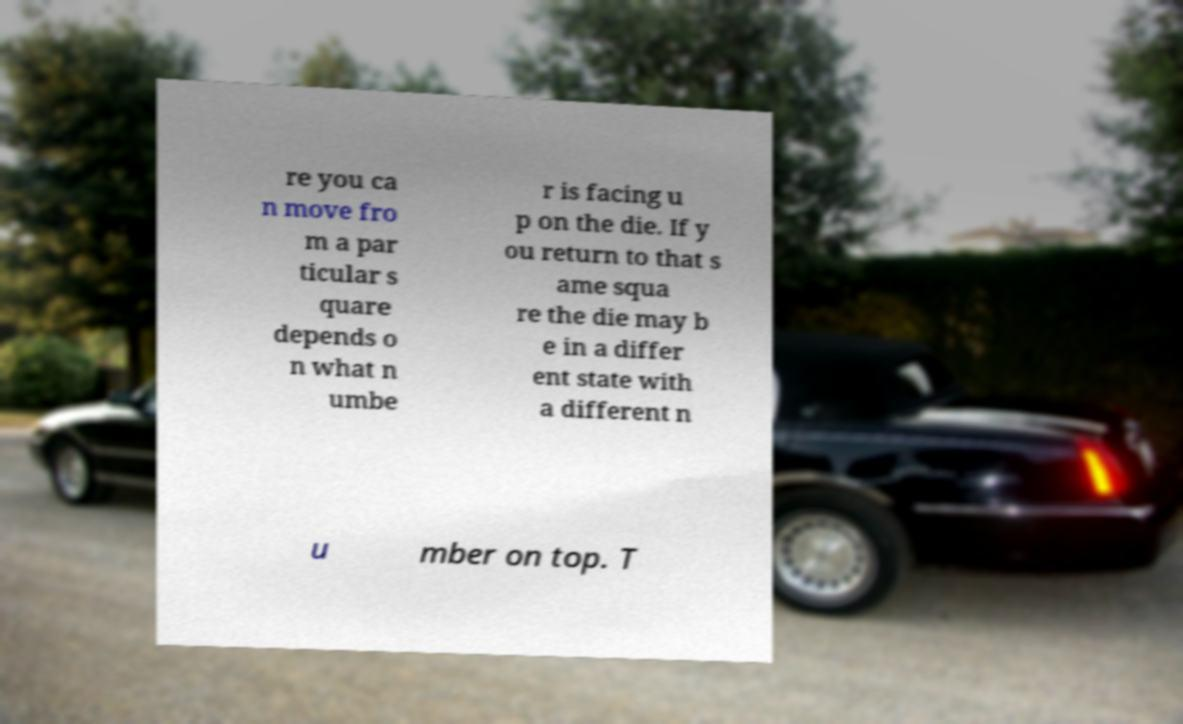Please read and relay the text visible in this image. What does it say? re you ca n move fro m a par ticular s quare depends o n what n umbe r is facing u p on the die. If y ou return to that s ame squa re the die may b e in a differ ent state with a different n u mber on top. T 